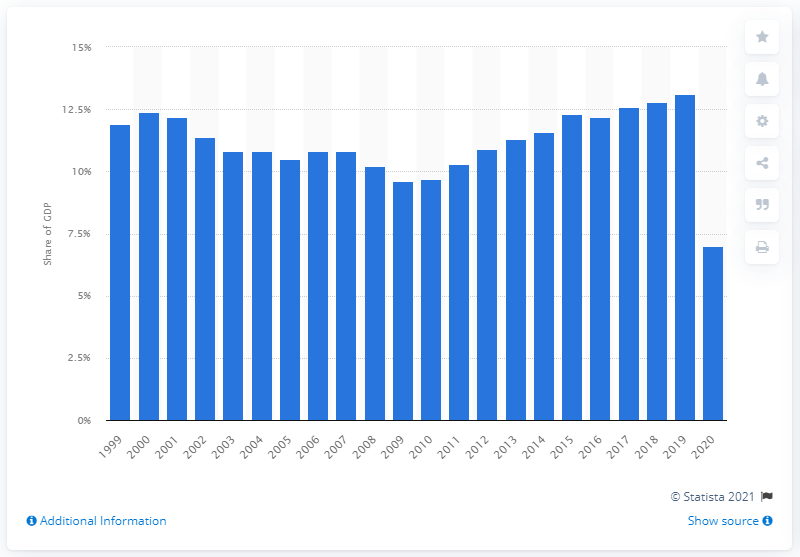Outline some significant characteristics in this image. In 2019, the highest percentage of tourism in Italy was 13.1%. 